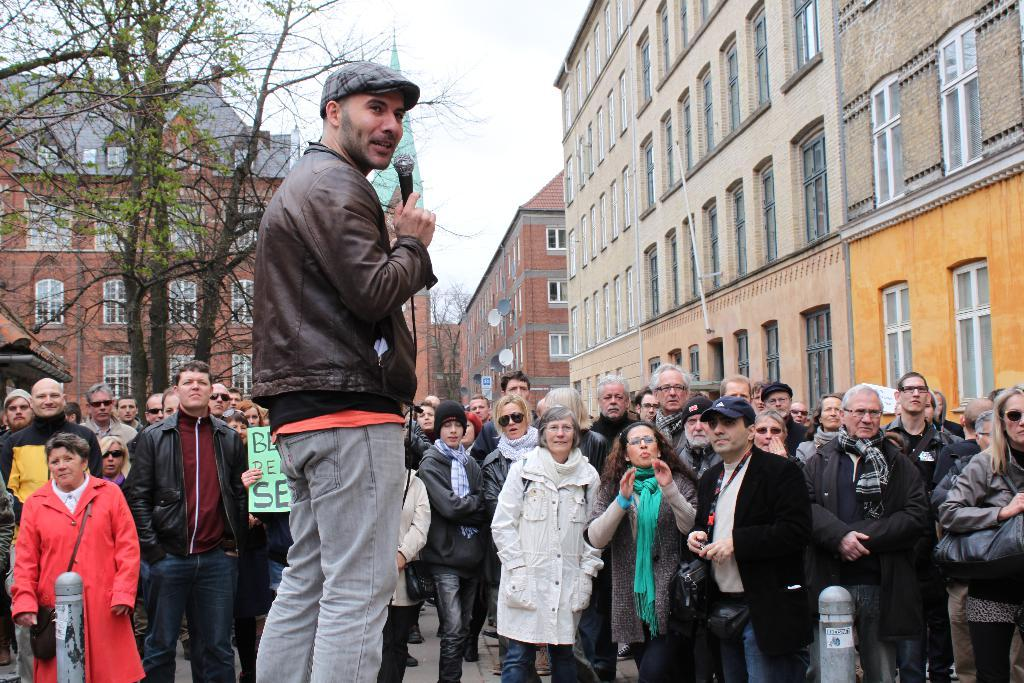What are the people in the image doing? The people in the image are standing on the ground. Can you describe the person holding a microphone in the image? There is a person holding a microphone in the image. What type of structures can be seen in the image? There are buildings in the image. What else can be seen in the image besides the people and buildings? There are poles, trees, and the sky visible in the image. What type of beds can be seen in the image? There are no beds present in the image. What is the person holding a microphone interested in? The image does not provide information about the person's interests, as it only shows them holding a microphone. 